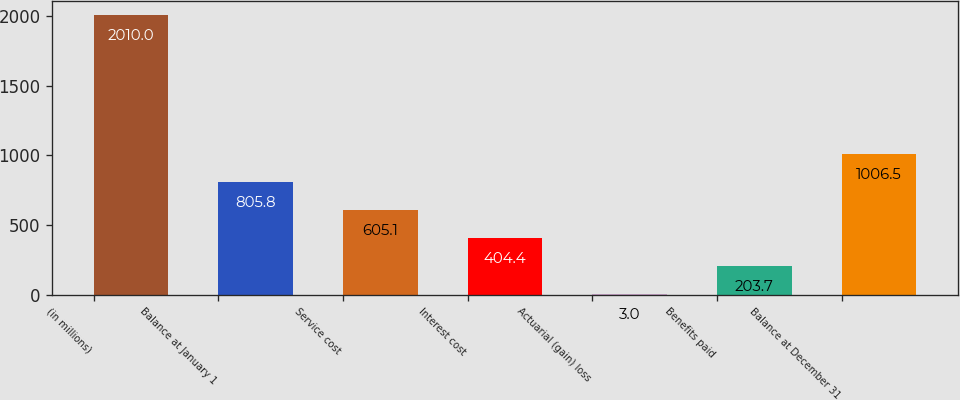Convert chart to OTSL. <chart><loc_0><loc_0><loc_500><loc_500><bar_chart><fcel>(in millions)<fcel>Balance at January 1<fcel>Service cost<fcel>Interest cost<fcel>Actuarial (gain) loss<fcel>Benefits paid<fcel>Balance at December 31<nl><fcel>2010<fcel>805.8<fcel>605.1<fcel>404.4<fcel>3<fcel>203.7<fcel>1006.5<nl></chart> 